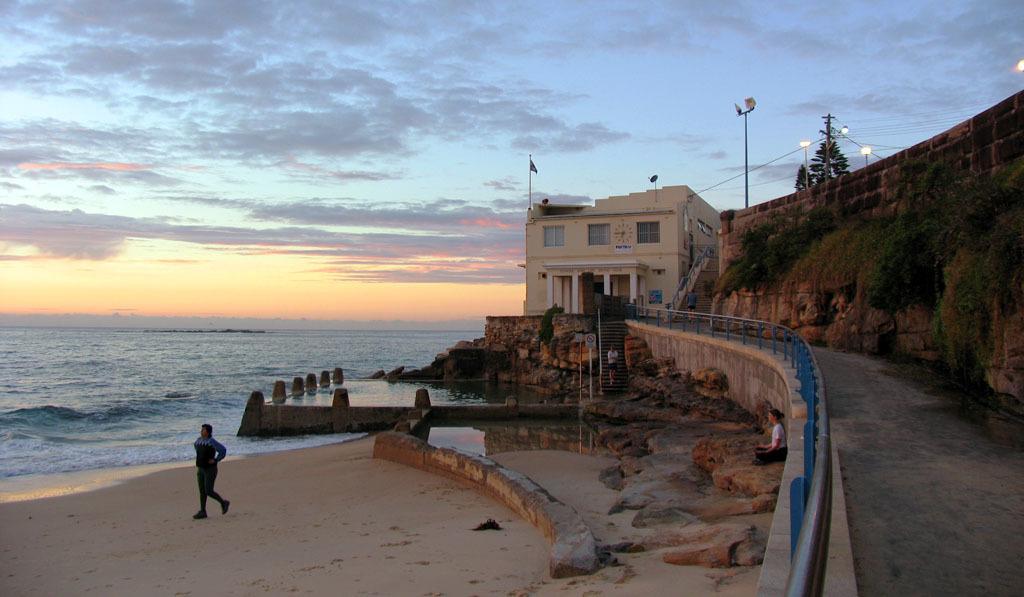How would you summarize this image in a sentence or two? In this image there is the sky truncated towards the top of the image, there are clouds in the sky, there is sea truncated towards the left of the image, there is a building, there are windows, there are pillars, there are stairs, there is a pole, there is a flag, there are persons, there is a wall truncated towards the right of the image, there are plants on the wall, there are lights, there is a tree, there is a light truncated towards the right of the image, there are rocks, there is a person walking, there is a person sitting, there is sand truncated towards the bottom of the image. 